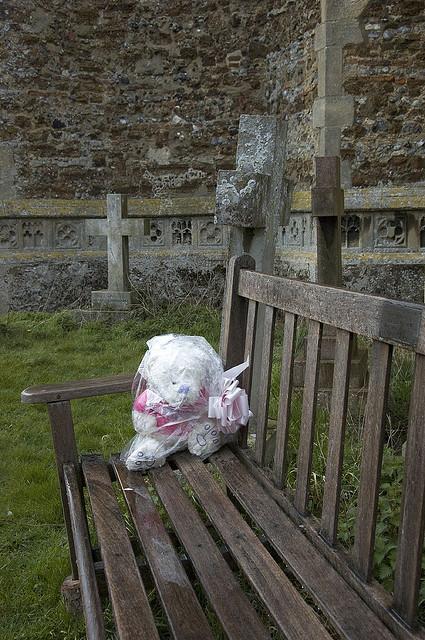What is the bench made of?
Write a very short answer. Wood. What is sitting on the park bench?
Write a very short answer. Stuffed animal. What color is the stuffed animal?
Be succinct. White. 